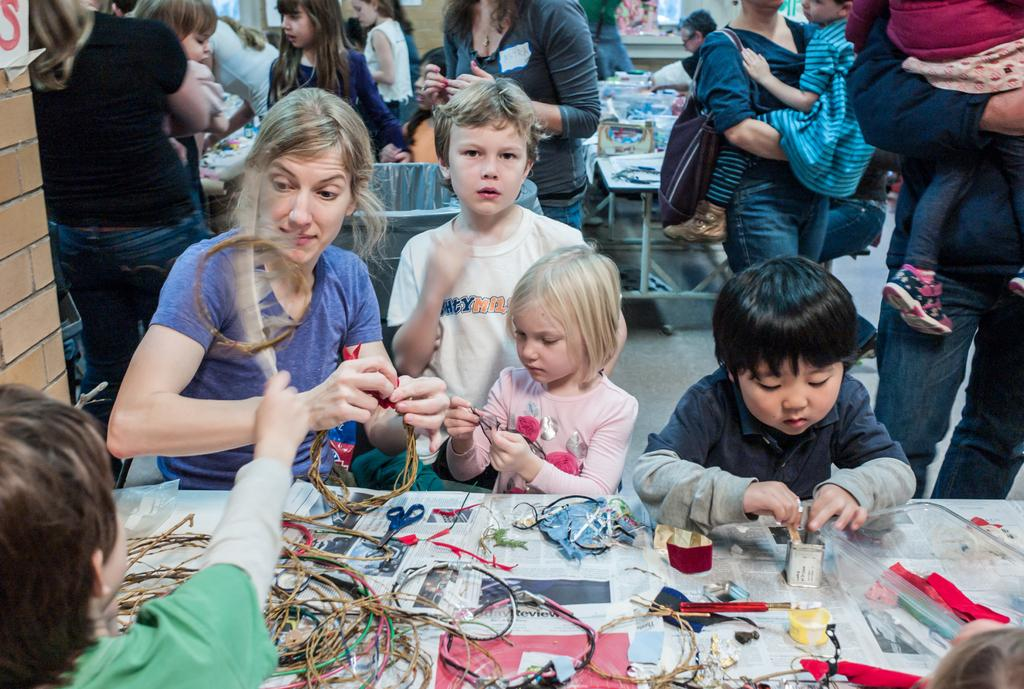Where is the table located in the image? The table is in the bottom right side of the image. What is on the table in the image? There are products on the table. Who or what can be seen at the top of the image? There are people at the top of the image. What is located at the top left side of the image? There is a wall at the top left side of the image. Can you hear the thunder in the image? There is no mention of thunder or any sound in the image, so it cannot be heard. How many ears are visible on the people at the top of the image? The number of ears cannot be determined from the image, as it only shows the presence of people but not their specific features. 